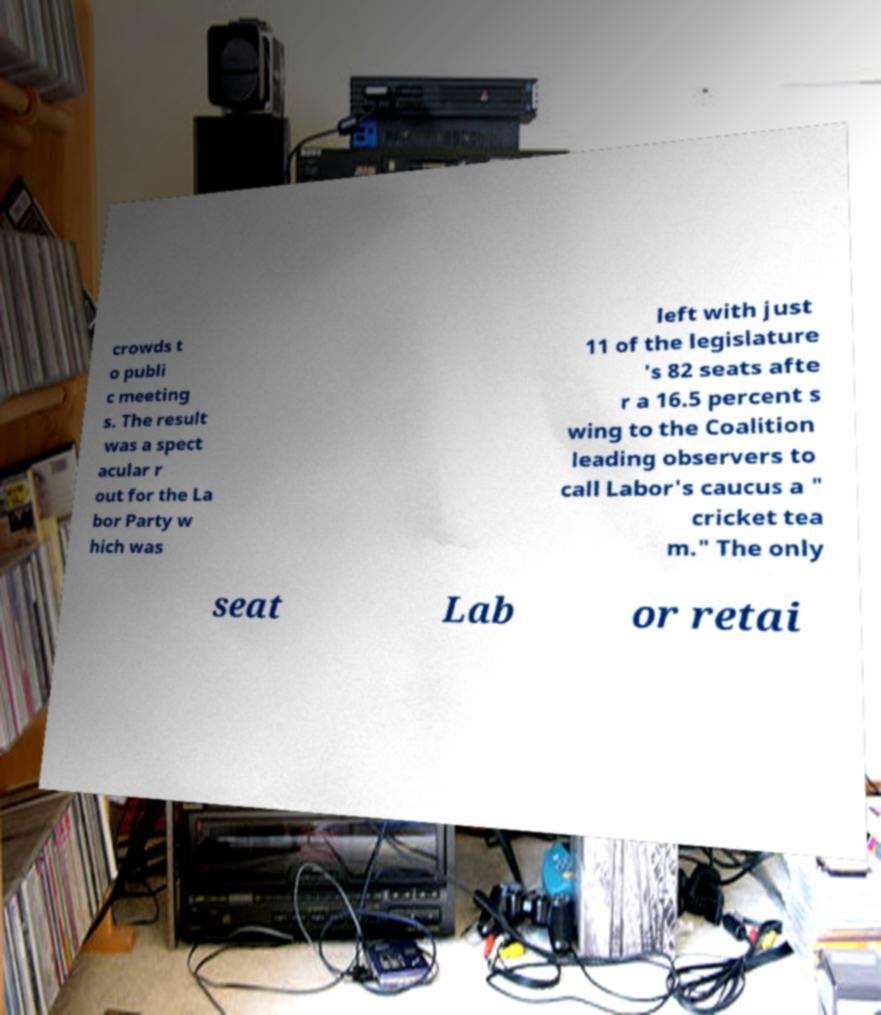Could you extract and type out the text from this image? crowds t o publi c meeting s. The result was a spect acular r out for the La bor Party w hich was left with just 11 of the legislature 's 82 seats afte r a 16.5 percent s wing to the Coalition leading observers to call Labor's caucus a " cricket tea m." The only seat Lab or retai 